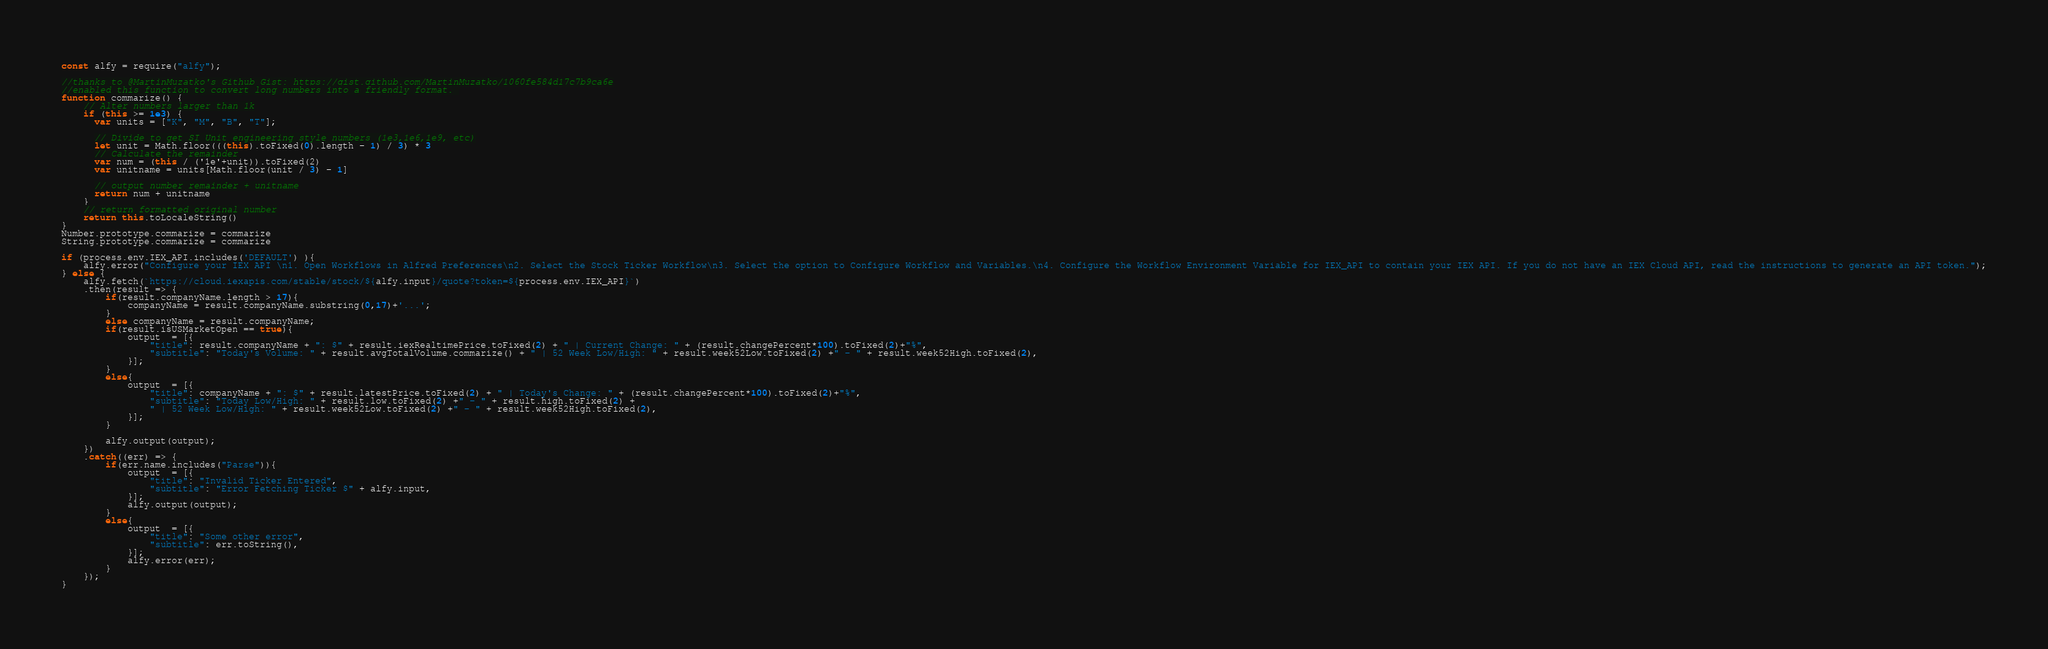<code> <loc_0><loc_0><loc_500><loc_500><_JavaScript_>const alfy = require("alfy");

//thanks to @MartinMuzatko's Github Gist: https://gist.github.com/MartinMuzatko/1060fe584d17c7b9ca6e
//enabled this function to convert long numbers into a friendly format. 
function commarize() {
	// Alter numbers larger than 1k
	if (this >= 1e3) {
	  var units = ["K", "M", "B", "T"];
	  
	  // Divide to get SI Unit engineering style numbers (1e3,1e6,1e9, etc)
	  let unit = Math.floor(((this).toFixed(0).length - 1) / 3) * 3
	  // Calculate the remainder
	  var num = (this / ('1e'+unit)).toFixed(2)
	  var unitname = units[Math.floor(unit / 3) - 1]
	  
	  // output number remainder + unitname
	  return num + unitname
	}
	// return formatted original number
	return this.toLocaleString()
}
Number.prototype.commarize = commarize
String.prototype.commarize = commarize

if (process.env.IEX_API.includes('DEFAULT') ){
	alfy.error("Configure your IEX API \n1. Open Workflows in Alfred Preferences\n2. Select the Stock Ticker Workflow\n3. Select the option to Configure Workflow and Variables.\n4. Configure the Workflow Environment Variable for IEX_API to contain your IEX API. If you do not have an IEX Cloud API, read the instructions to generate an API token.");
} else {
	alfy.fetch(`https://cloud.iexapis.com/stable/stock/${alfy.input}/quote?token=${process.env.IEX_API}`)
	.then(result => {
		if(result.companyName.length > 17){
			companyName = result.companyName.substring(0,17)+'...';
		}
		else companyName = result.companyName;
		if(result.isUSMarketOpen == true){
			output  = [{
				"title": result.companyName + ": $" + result.iexRealtimePrice.toFixed(2) + " | Current Change: " + (result.changePercent*100).toFixed(2)+"%",
				"subtitle": "Today's Volume: " + result.avgTotalVolume.commarize() + " | 52 Week Low/High: " + result.week52Low.toFixed(2) +" - " + result.week52High.toFixed(2),
			}];
		}
		else{
			output  = [{
				"title": companyName + ": $" + result.latestPrice.toFixed(2) + " | Today's Change: " + (result.changePercent*100).toFixed(2)+"%",
				"subtitle": "Today Low/High: " + result.low.toFixed(2) +" - " + result.high.toFixed(2) + 
				" | 52 Week Low/High: " + result.week52Low.toFixed(2) +" - " + result.week52High.toFixed(2),
			}];
		}
		
		alfy.output(output);
	})
	.catch((err) => {
		if(err.name.includes("Parse")){
			output  = [{
				"title": "Invalid Ticker Entered",
				"subtitle": "Error Fetching Ticker $" + alfy.input,
			}];
			alfy.output(output);
		}
		else{
			output  = [{
				"title": "Some other error",
				"subtitle": err.toString(),
			}];
			alfy.error(err);
		}
	});
}
</code> 